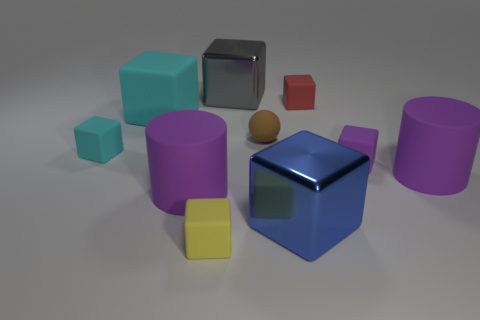What is the blue thing made of?
Ensure brevity in your answer.  Metal. Is there any other thing of the same color as the tiny rubber ball?
Offer a terse response. No. Is the yellow object the same shape as the big cyan thing?
Provide a short and direct response. Yes. There is a sphere that is right of the large purple cylinder that is in front of the rubber cylinder that is right of the tiny yellow matte object; what is its size?
Provide a short and direct response. Small. What number of other things are made of the same material as the small yellow object?
Your answer should be very brief. 7. There is a small matte block behind the brown ball; what color is it?
Offer a very short reply. Red. What is the purple thing that is in front of the big cylinder behind the large cylinder to the left of the red thing made of?
Keep it short and to the point. Rubber. Are there any other things of the same shape as the small cyan matte object?
Ensure brevity in your answer.  Yes. There is a red matte object that is the same size as the yellow cube; what shape is it?
Provide a short and direct response. Cube. How many objects are to the left of the tiny rubber sphere and in front of the large gray metallic thing?
Provide a short and direct response. 4. 